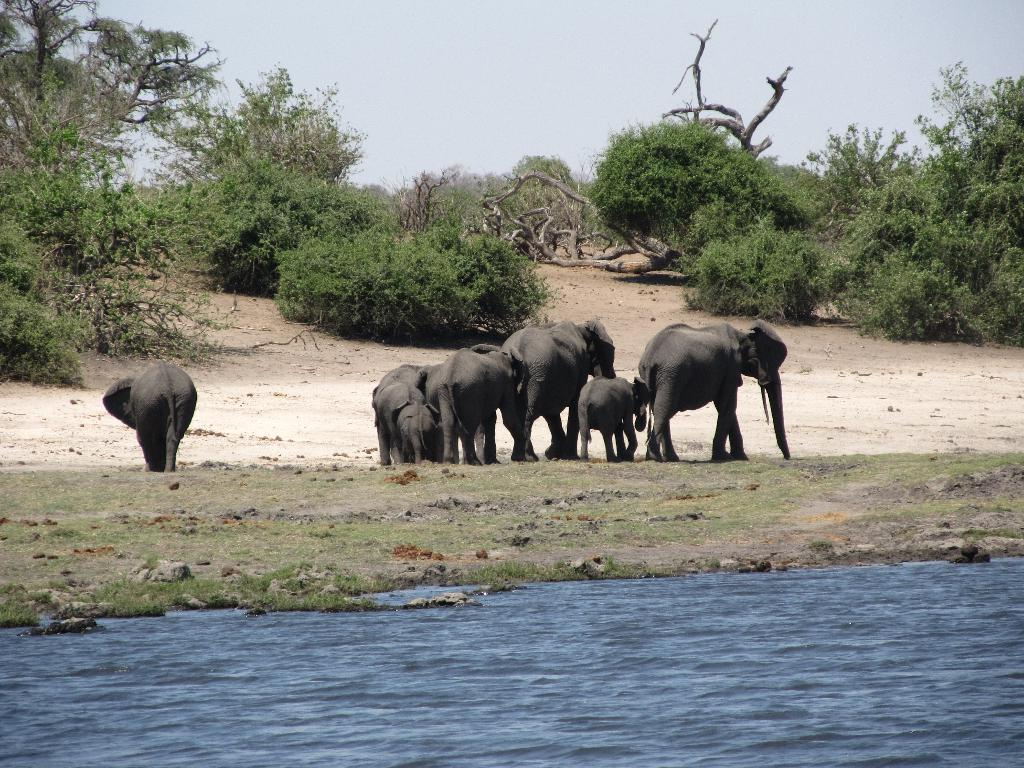What animals are present in the image? There are elephants in the image. What type of vegetation is on the ground in the image? There is green grass on the ground. What else can be seen besides the elephants and grass? There is water visible in the image. What can be seen in the distance in the image? There are trees in the background of the image. What is visible at the top of the image? The sky is visible at the top of the image. What type of hat is the elephant wearing in the image? There are no hats visible on the elephants in the image. Is there a road visible in the image? There is no road present in the image. 